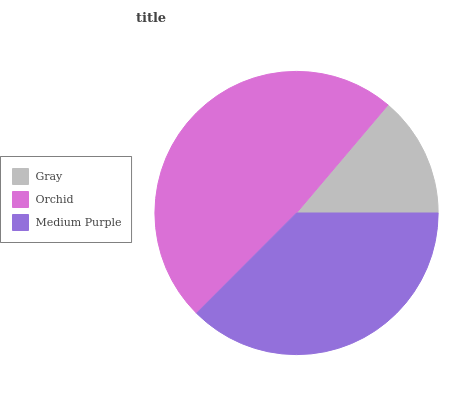Is Gray the minimum?
Answer yes or no. Yes. Is Orchid the maximum?
Answer yes or no. Yes. Is Medium Purple the minimum?
Answer yes or no. No. Is Medium Purple the maximum?
Answer yes or no. No. Is Orchid greater than Medium Purple?
Answer yes or no. Yes. Is Medium Purple less than Orchid?
Answer yes or no. Yes. Is Medium Purple greater than Orchid?
Answer yes or no. No. Is Orchid less than Medium Purple?
Answer yes or no. No. Is Medium Purple the high median?
Answer yes or no. Yes. Is Medium Purple the low median?
Answer yes or no. Yes. Is Orchid the high median?
Answer yes or no. No. Is Gray the low median?
Answer yes or no. No. 